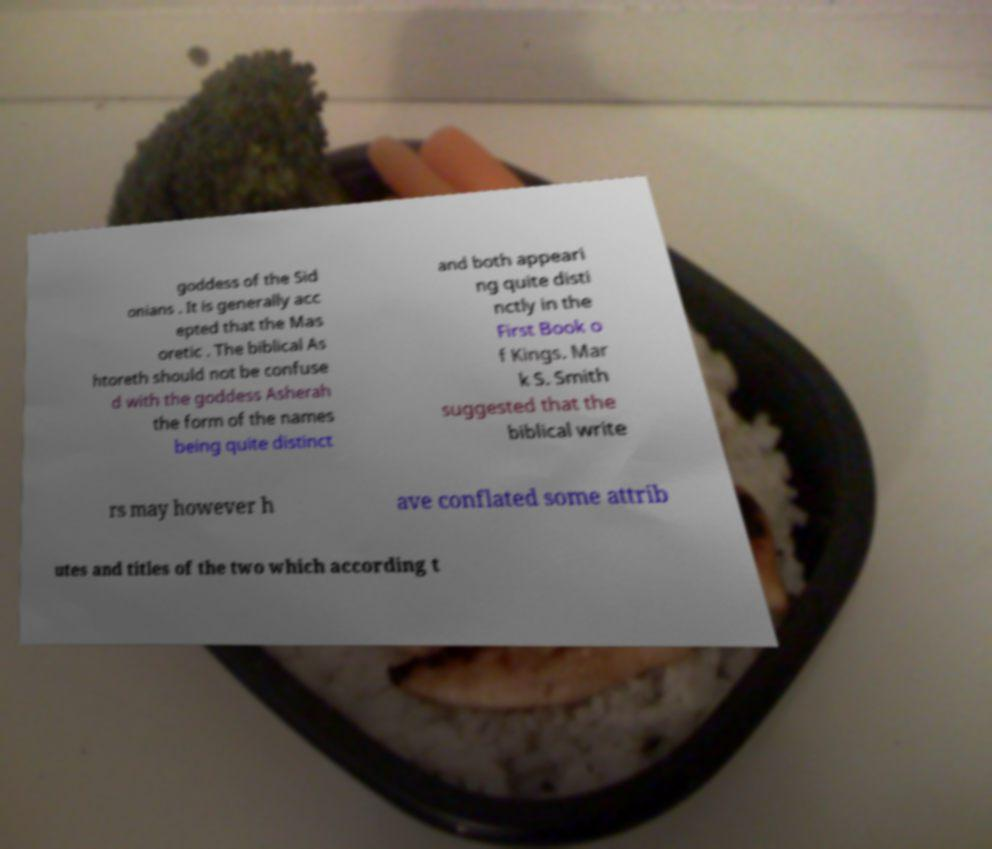Could you assist in decoding the text presented in this image and type it out clearly? goddess of the Sid onians . It is generally acc epted that the Mas oretic . The biblical As htoreth should not be confuse d with the goddess Asherah the form of the names being quite distinct and both appeari ng quite disti nctly in the First Book o f Kings. Mar k S. Smith suggested that the biblical write rs may however h ave conflated some attrib utes and titles of the two which according t 